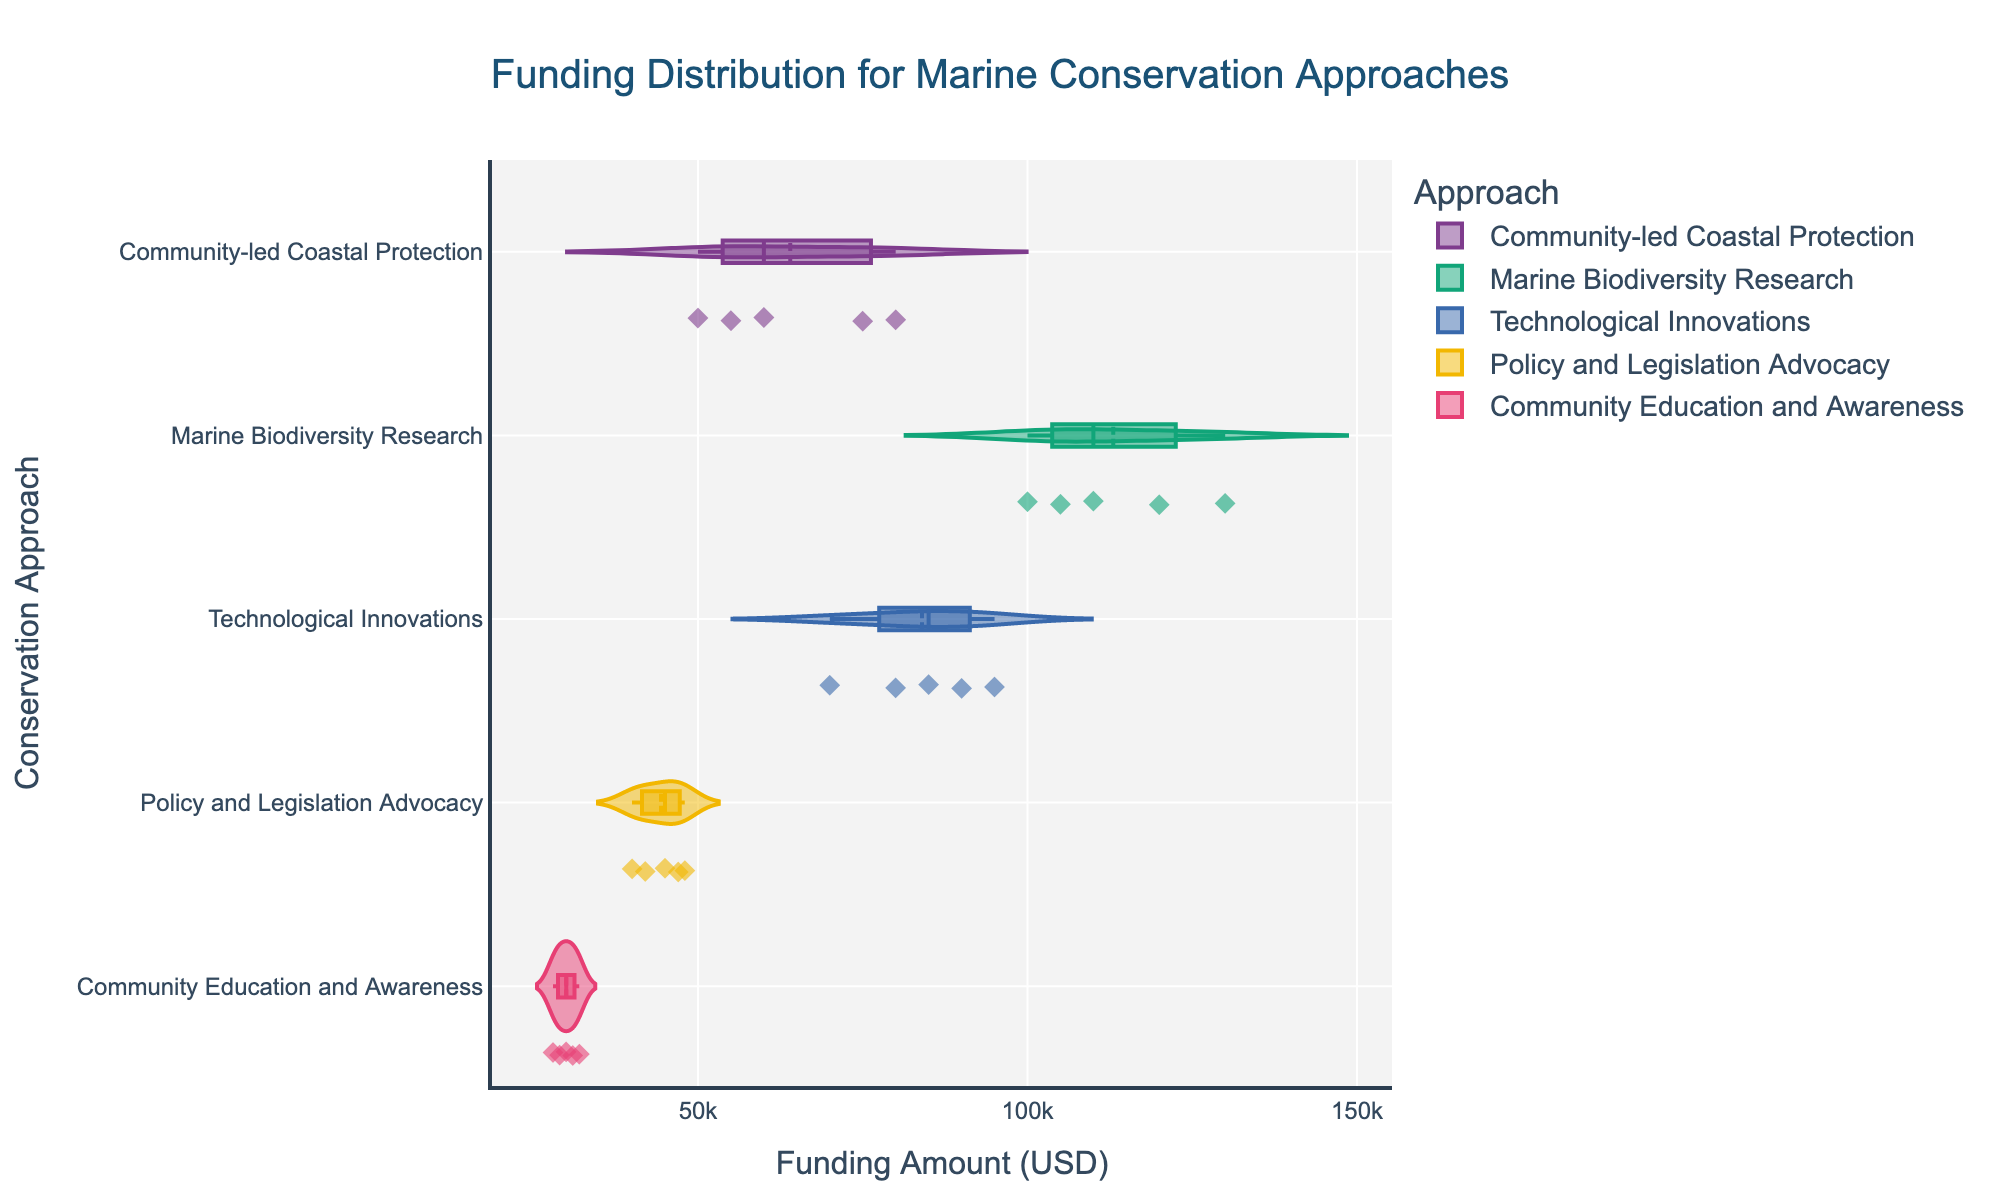What is the title of the figure? The title of the figure is located at the top of the plot. It helps describe the overall content of the visualization. By reading the title text, we can determine it.
Answer: Funding Distribution for Marine Conservation Approaches Which conservation approach has the highest median funding amount? Observe the median lines (usually the center of the shaded area or where the box plot is located) within each violin plot. Identify which median is the highest.
Answer: Marine Biodiversity Research How many data points are there for the 'Community-led Coastal Protection' approach? Count the number of individual points (typically represented by diamonds) within the 'Community-led Coastal Protection' violin plot. Each point represents a single data value.
Answer: 5 What is the range of funding amounts for the 'Policy and Legislation Advocacy' approach? The range is found by identifying the minimum and maximum points within the 'Policy and Legislation Advocacy' violin plot. The minimum value is the lowest point, and the maximum is the highest point.
Answer: $40,000 to $48,000 Which approach shows the greatest variation in funding amounts? Variation can be assessed by observing the width and span of each violin plot. The approach with the widest and most spread-out plot indicates the greatest variation.
Answer: Marine Biodiversity Research Which conservation approach appears to have the smallest interquartile range (IQR) of funding amounts? The IQR is represented by the length of the box inside each violin plot. Locate the smallest box to identify which has the smallest IQR.
Answer: Policy and Legislation Advocacy Are there any outliers in the 'Marine Biodiversity Research' approach? Outliers are typically shown as individual points outside the main body of the violin plot. Check for any separate points within the 'Marine Biodiversity Research' approach.
Answer: No How does the average funding amount of 'Community-led Coastal Protection' compare to that of 'Technological Innovations'? Calculate the average value by summing the funding amounts and then dividing by the number of points for each approach. Compare the averages to determine the relationship.
Answer: Community-led Coastal Protection: $64,000, Technological Innovations: $84,000. The average for Technological Innovations is higher 